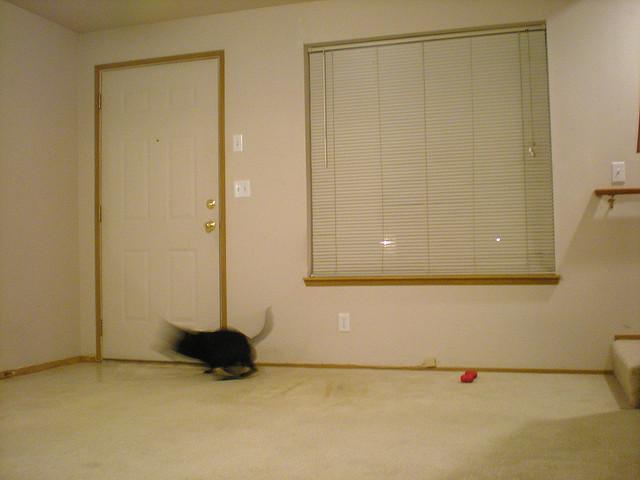Why is the cat fuzzy?
Concise answer only. Running. What red object is that on the floor?
Quick response, please. Toy. Are there any furnishings visible in the image?
Give a very brief answer. No. 